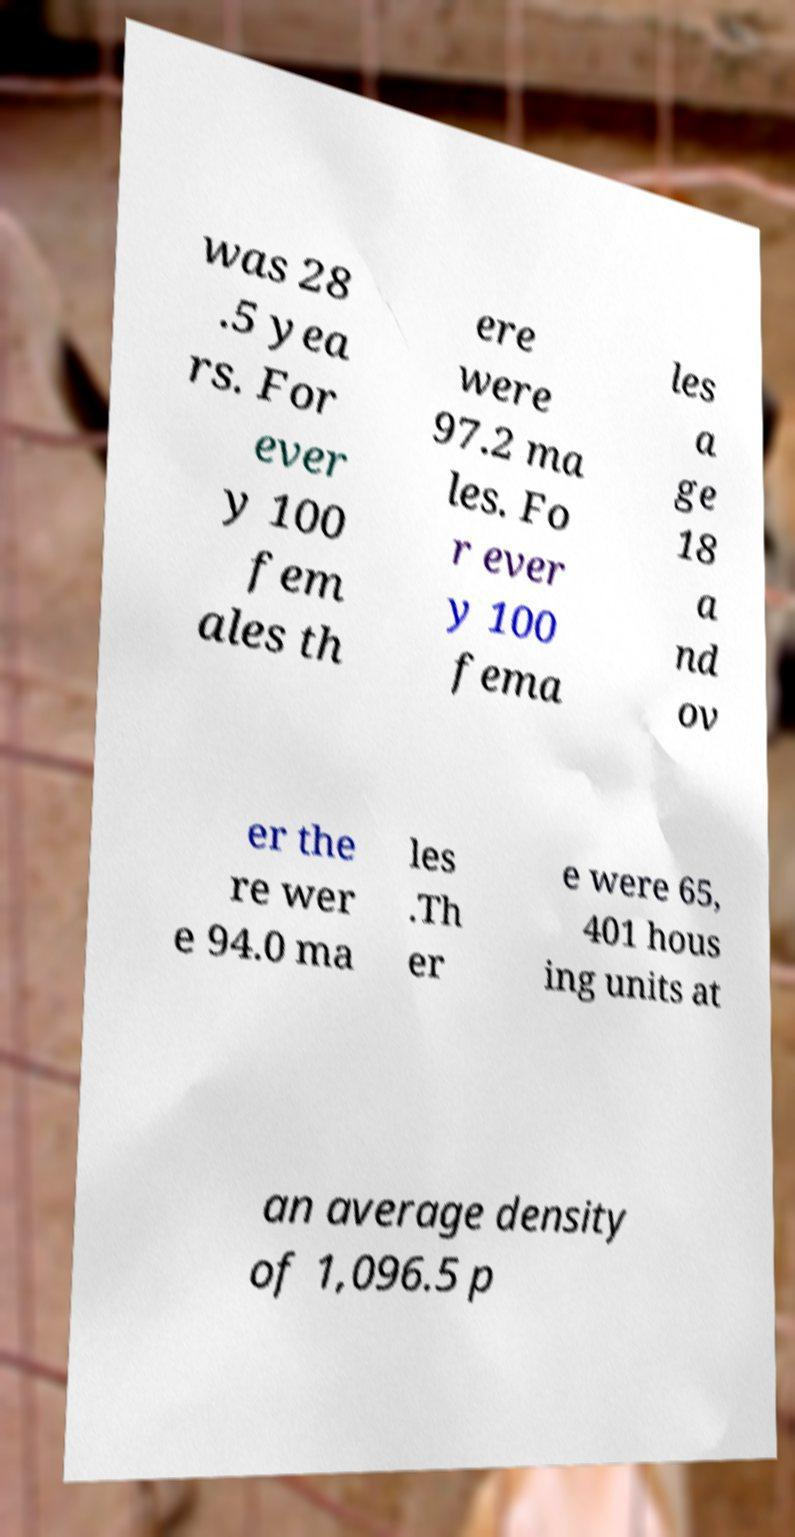I need the written content from this picture converted into text. Can you do that? was 28 .5 yea rs. For ever y 100 fem ales th ere were 97.2 ma les. Fo r ever y 100 fema les a ge 18 a nd ov er the re wer e 94.0 ma les .Th er e were 65, 401 hous ing units at an average density of 1,096.5 p 